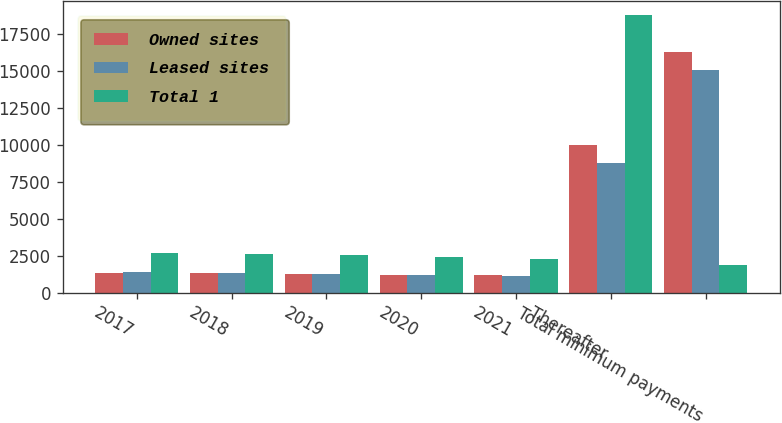Convert chart to OTSL. <chart><loc_0><loc_0><loc_500><loc_500><stacked_bar_chart><ecel><fcel>2017<fcel>2018<fcel>2019<fcel>2020<fcel>2021<fcel>Thereafter<fcel>Total minimum payments<nl><fcel>Owned sites<fcel>1319.1<fcel>1290.6<fcel>1261<fcel>1219.9<fcel>1167.5<fcel>10018.5<fcel>16276.6<nl><fcel>Leased sites<fcel>1370.5<fcel>1327<fcel>1279.1<fcel>1205.9<fcel>1127.4<fcel>8745.2<fcel>15055.1<nl><fcel>Total 1<fcel>2689.6<fcel>2617.6<fcel>2540.1<fcel>2425.8<fcel>2294.9<fcel>18763.7<fcel>1832.7<nl></chart> 